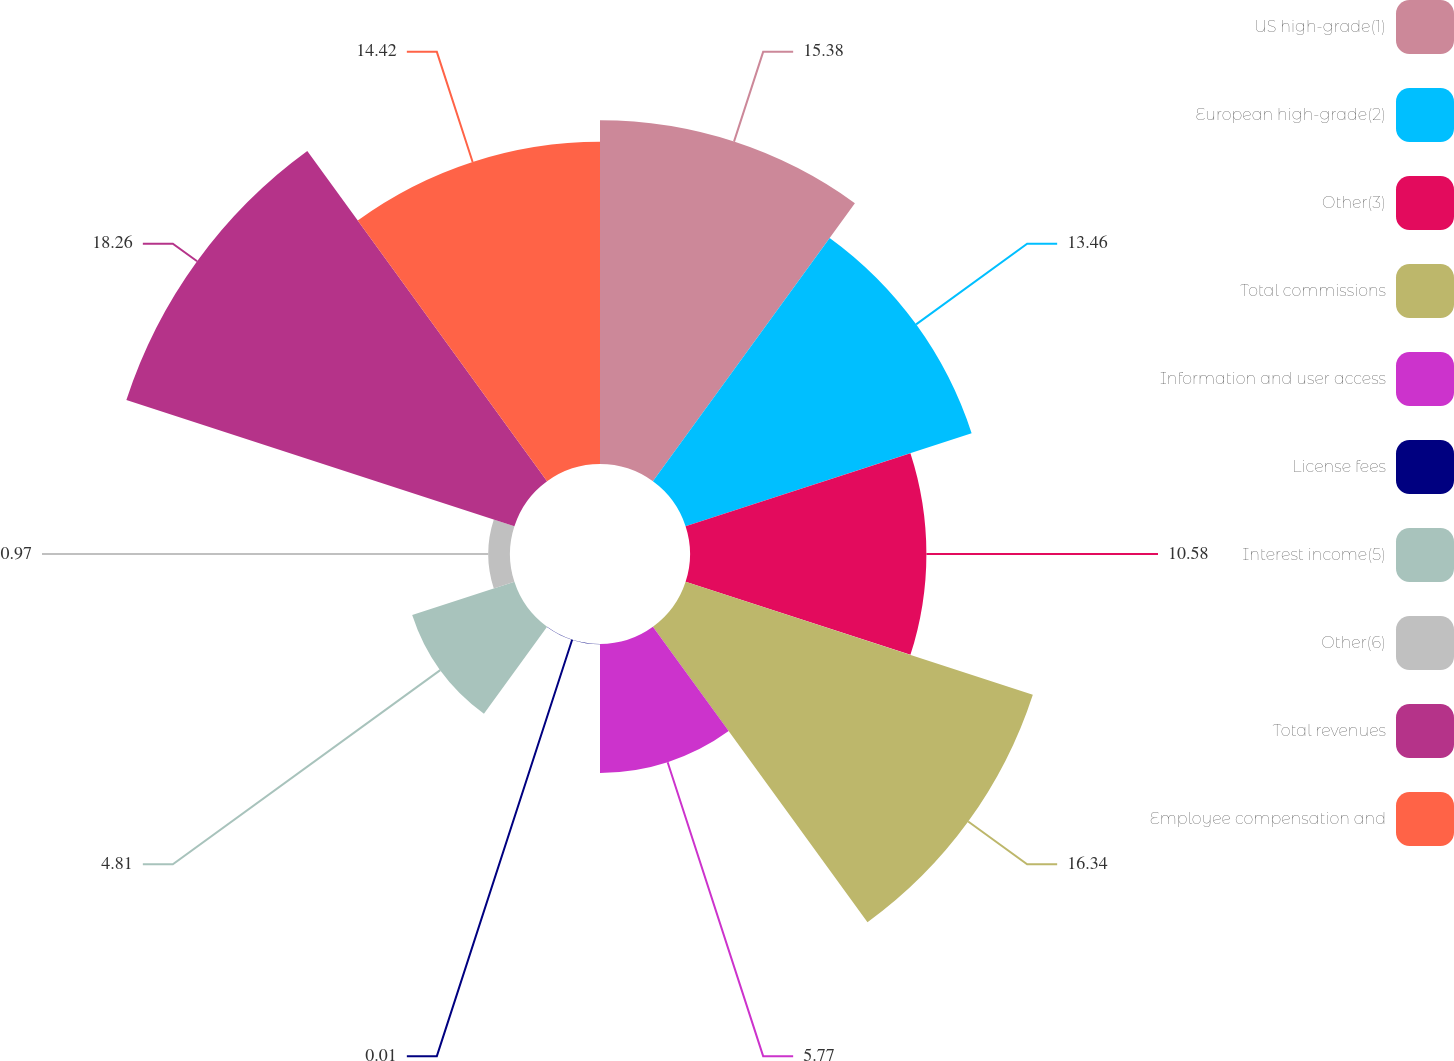Convert chart to OTSL. <chart><loc_0><loc_0><loc_500><loc_500><pie_chart><fcel>US high-grade(1)<fcel>European high-grade(2)<fcel>Other(3)<fcel>Total commissions<fcel>Information and user access<fcel>License fees<fcel>Interest income(5)<fcel>Other(6)<fcel>Total revenues<fcel>Employee compensation and<nl><fcel>15.38%<fcel>13.46%<fcel>10.58%<fcel>16.34%<fcel>5.77%<fcel>0.01%<fcel>4.81%<fcel>0.97%<fcel>18.26%<fcel>14.42%<nl></chart> 